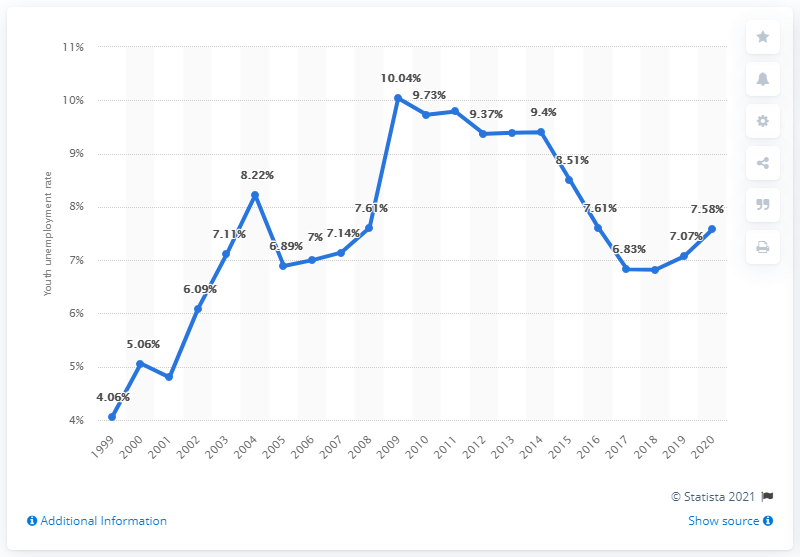Mention a couple of crucial points in this snapshot. According to data from 2020, the youth unemployment rate in Mexico was 7.58%. 